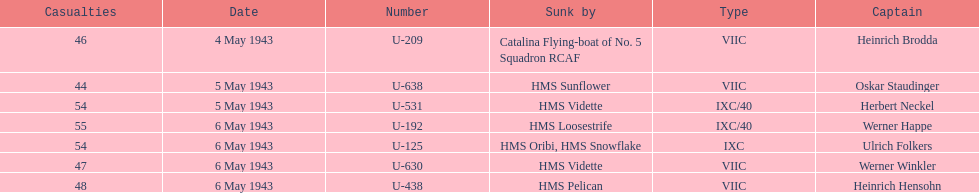How many captains are listed? 7. 